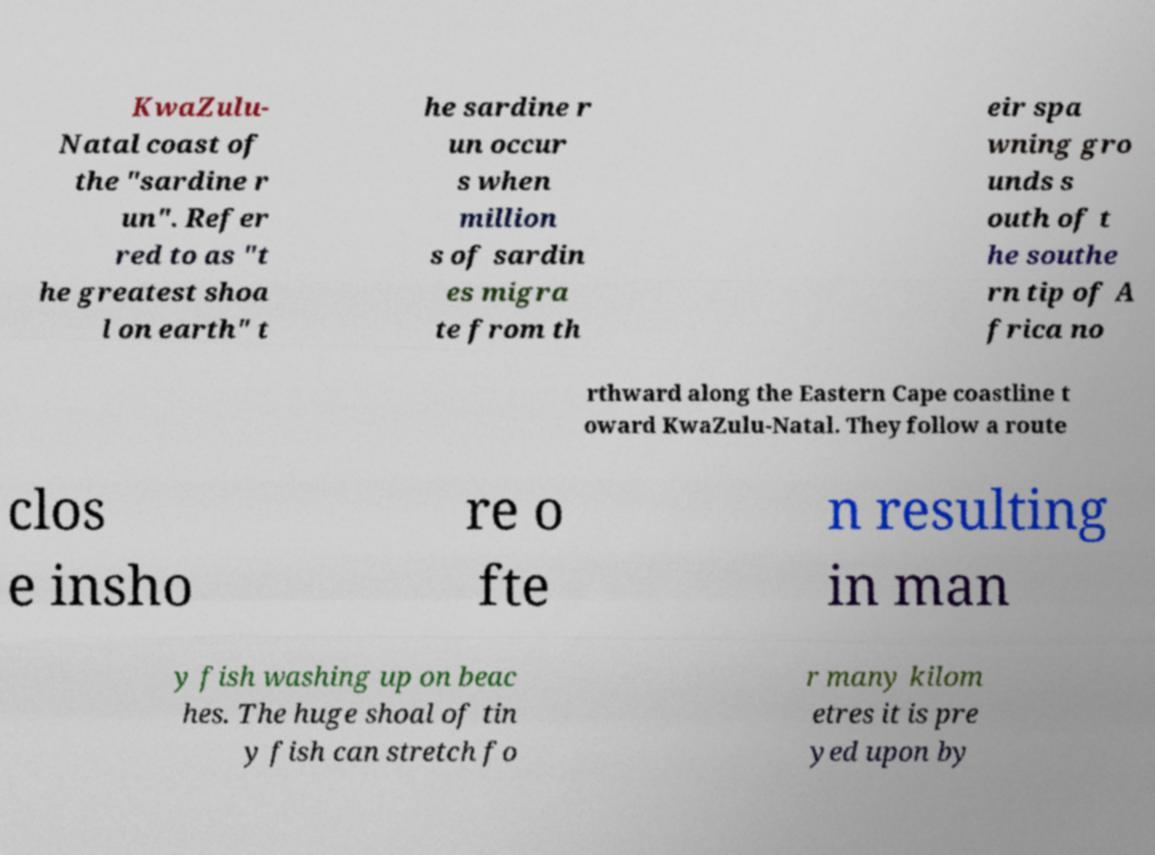Can you accurately transcribe the text from the provided image for me? KwaZulu- Natal coast of the "sardine r un". Refer red to as "t he greatest shoa l on earth" t he sardine r un occur s when million s of sardin es migra te from th eir spa wning gro unds s outh of t he southe rn tip of A frica no rthward along the Eastern Cape coastline t oward KwaZulu-Natal. They follow a route clos e insho re o fte n resulting in man y fish washing up on beac hes. The huge shoal of tin y fish can stretch fo r many kilom etres it is pre yed upon by 